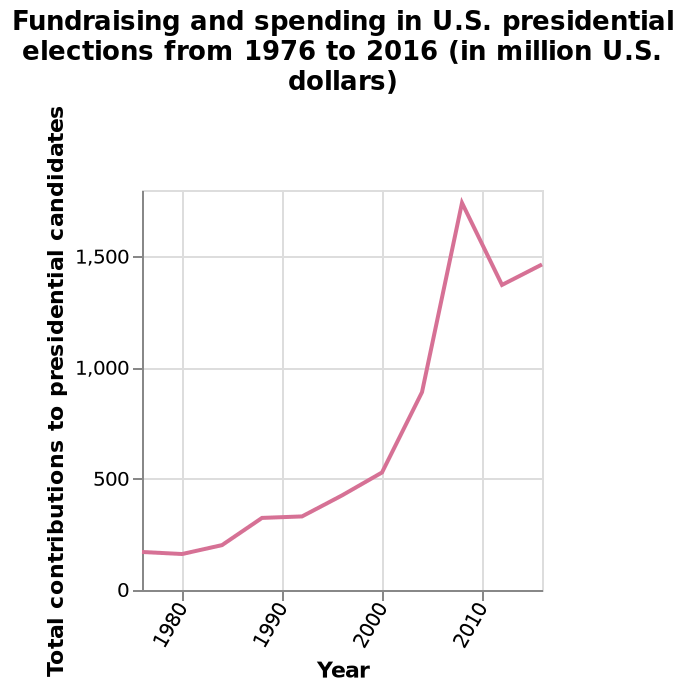<image>
please summary the statistics and relations of the chart The highest level of fundraising and expenditure on US campaign elections was in the 2008 elections. The level of expenditure trebled in 2008 in comparison to the 2000 elections. In the period between 1976 and 2016, there is a general upwards trend in the level of expenditure. When was the highest level of fundraising and expenditure on US campaign elections?  The highest level of fundraising and expenditure on US campaign elections was in 2008. 